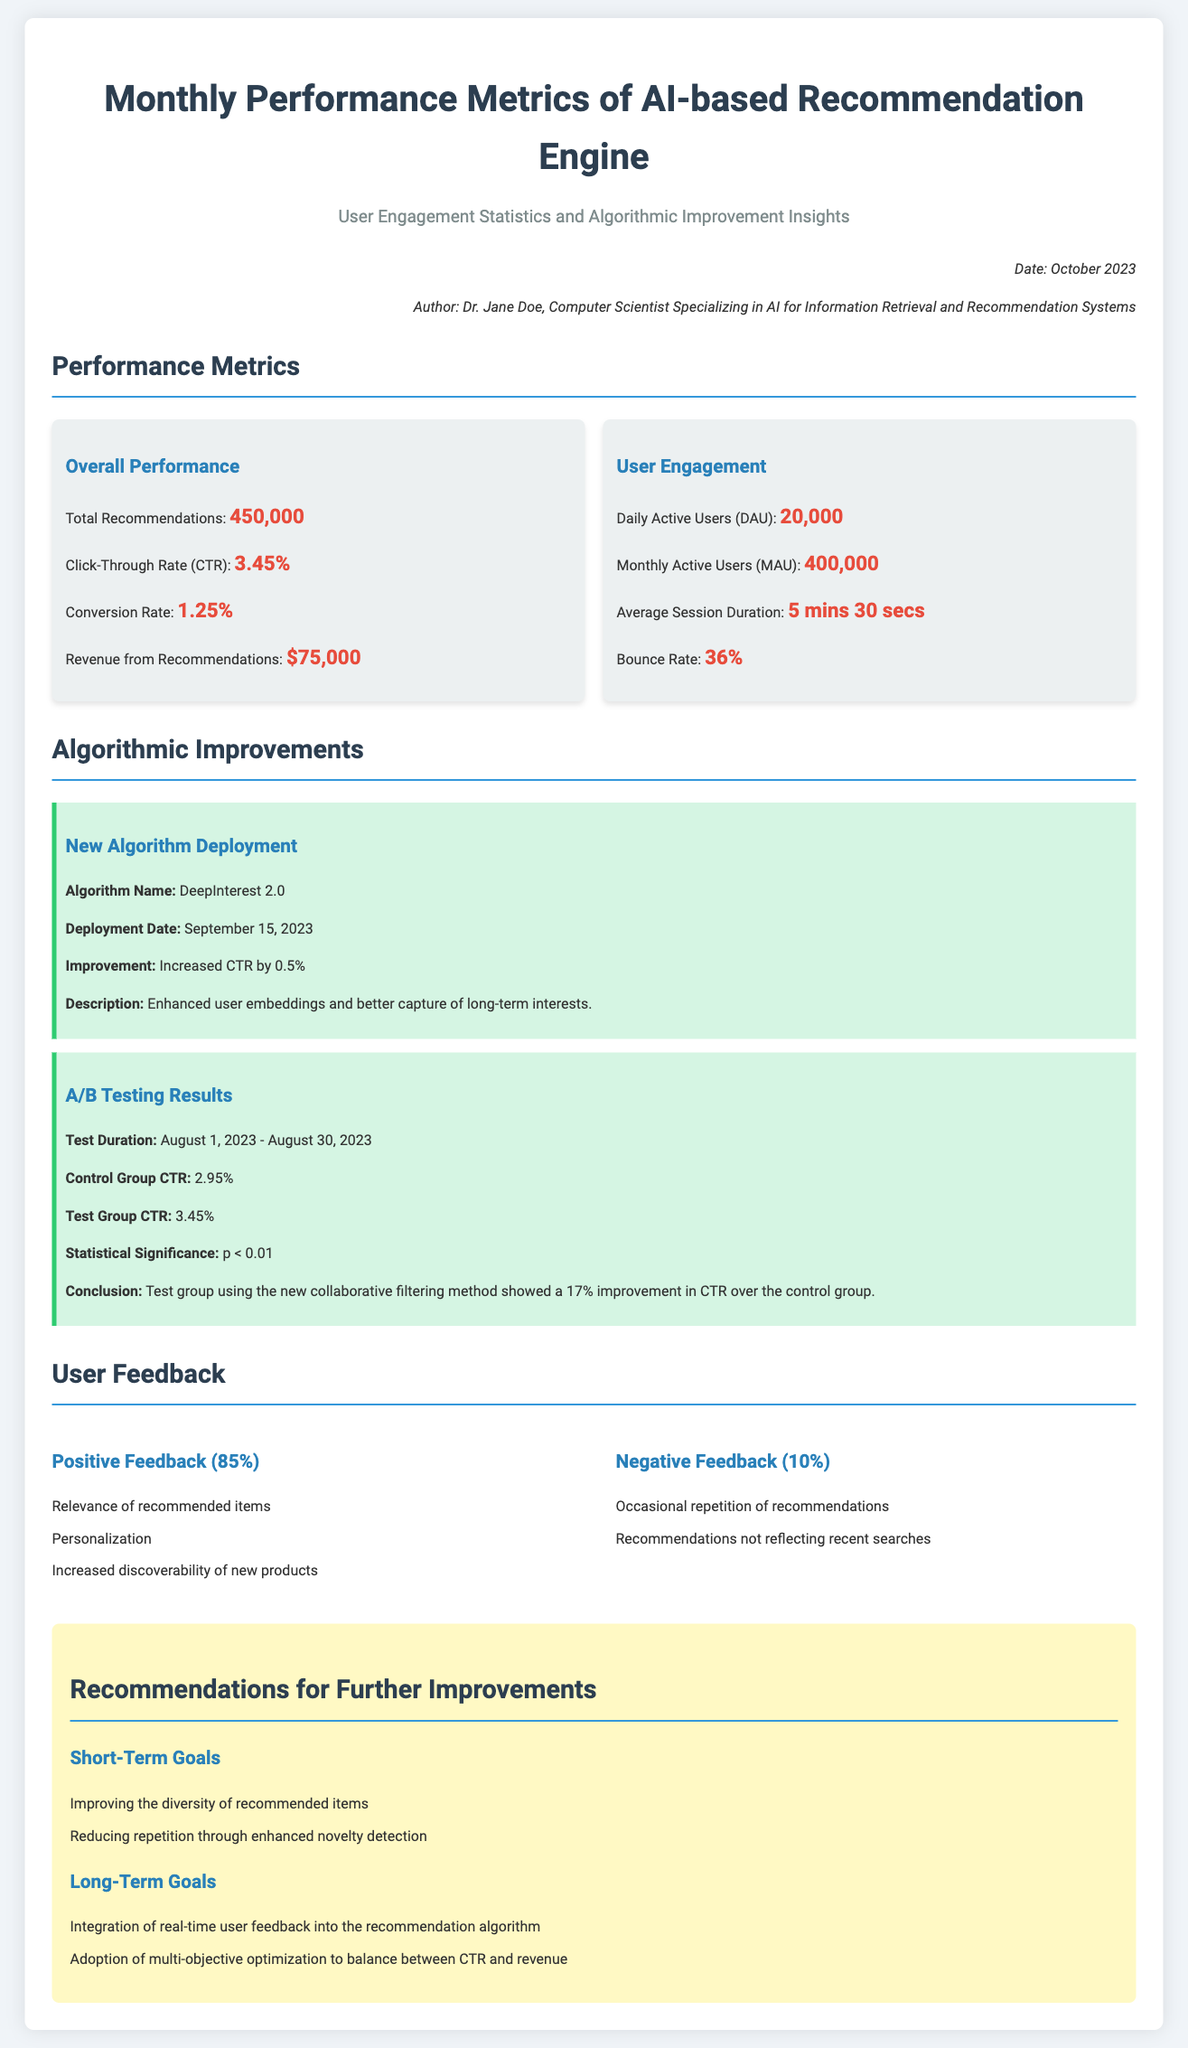What is the total number of recommendations? The total number of recommendations is stated in the performance metrics section of the document, which is 450,000.
Answer: 450,000 What is the conversion rate? The conversion rate is a key performance metric listed in the document, which is 1.25%.
Answer: 1.25% What is the monthly active user count? The monthly active user count is found under user engagement metrics in the document, which is 400,000.
Answer: 400,000 What was the click-through rate before the new algorithm deployment? The click-through rate before the new algorithm was the control group CTR stated in the A/B testing results, which is 2.95%.
Answer: 2.95% What is the name of the new algorithm deployed? The document specifically lists the new algorithm deployed as DeepInterest 2.0.
Answer: DeepInterest 2.0 What percentage of feedback was positive? The percentage of positive feedback is mentioned in the user feedback section, which is 85%.
Answer: 85% What was the average session duration? The average session duration is specified in the user engagement statistics as 5 mins 30 secs.
Answer: 5 mins 30 secs What is a short-term goal mentioned for further improvements? The document lists several short-term goals, one of which is improving the diversity of recommended items.
Answer: Improving the diversity of recommended items What was the statistical significance of the A/B test? The document states the statistical significance of the A/B test as p < 0.01.
Answer: p < 0.01 